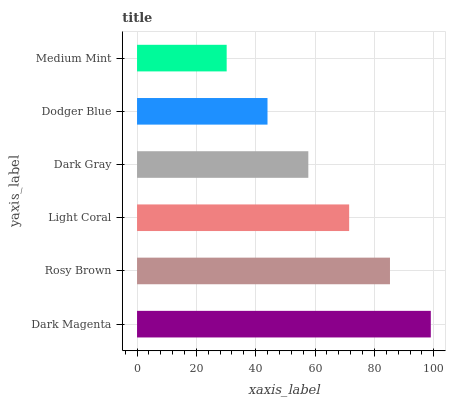Is Medium Mint the minimum?
Answer yes or no. Yes. Is Dark Magenta the maximum?
Answer yes or no. Yes. Is Rosy Brown the minimum?
Answer yes or no. No. Is Rosy Brown the maximum?
Answer yes or no. No. Is Dark Magenta greater than Rosy Brown?
Answer yes or no. Yes. Is Rosy Brown less than Dark Magenta?
Answer yes or no. Yes. Is Rosy Brown greater than Dark Magenta?
Answer yes or no. No. Is Dark Magenta less than Rosy Brown?
Answer yes or no. No. Is Light Coral the high median?
Answer yes or no. Yes. Is Dark Gray the low median?
Answer yes or no. Yes. Is Rosy Brown the high median?
Answer yes or no. No. Is Medium Mint the low median?
Answer yes or no. No. 